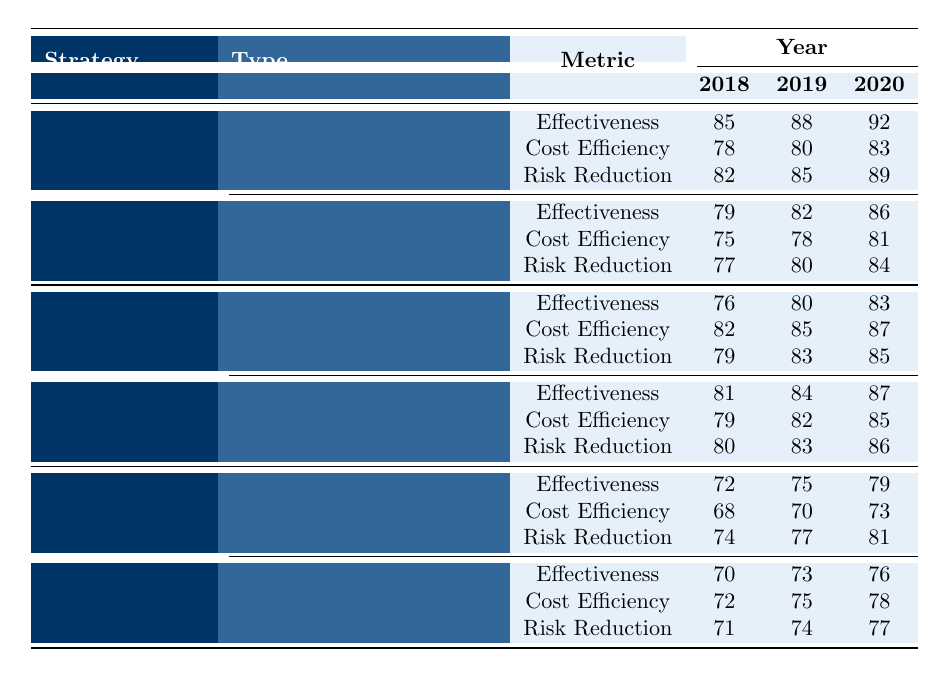What was the effectiveness of Currency Hedging in 2019? In the table under the Currency Hedging type, the effectiveness for the year 2019 is indicated as 88.
Answer: 88 What is the highest Risk Reduction value recorded for Hedging strategies? The highest Risk Reduction value for Hedging strategies is found under Currency Hedging in 2020, which is 89.
Answer: 89 Which diversification type had the highest cost efficiency in 2020? The table shows that Asset Class Diversification had a cost efficiency of 85 in 2020, which is higher than that of Geographic Diversification at 87.
Answer: 85 Did the effectiveness of Credit Default Swaps improve every year? Looking at the effectiveness values for Credit Default Swaps, they increased from 72 in 2018 to 75 in 2019 and then to 79 in 2020, indicating a consistent improvement.
Answer: Yes What was the average effectiveness of Interest Rate Swaps over the three years? The effectiveness values for Interest Rate Swaps are 79, 82, and 86. To find the average, sum them up: 79 + 82 + 86 = 247, and then divide by 3, resulting in 247/3 = 82.33.
Answer: 82.33 What was the cost efficiency of Operational Risk Insurance in 2019? According to the table, the cost efficiency of Operational Risk Insurance in 2019 is listed as 75.
Answer: 75 Which risk mitigation strategy showed the smallest improvement in effectiveness from 2018 to 2020? For the strategies not including Hedging, Geographic Diversification increased from 76 in 2018 to 83 in 2020, showing an increase of 7. In contrast, Credit Default Swaps improved from 72 to 79, which equals an increase of 7 as well. So, both strategies showed the same smallest improvement of 7%.
Answer: Both strategies showed equal improvement Was the effectiveness of Asset Class Diversification higher than Geographic Diversification in all years? The effectiveness values for Asset Class Diversification are 81, 84, and 87, while those for Geographic Diversification are 76, 80, and 83. In all three years, Asset Class Diversification has been higher than or equal to Geographic Diversification.
Answer: Yes In which strategy type did Risk Reduction see the greatest increase from 2018 to 2020? The Risk Reduction values for Credit Default Swaps increased from 74 in 2018 to 81 in 2020, which is an increase of 7 points. In Operational Risk Insurance, it increased from 71 to 77, which is also an increase of 6 points. Credit Default Swaps had the greatest increase of 7 points.
Answer: Credit Default Swaps What is the overall trend in cost efficiency for all risk mitigation strategies from 2018 to 2020? Examining the cost efficiency across all strategies, Hedging maintained a gradual increase, Diversification mostly increased, but Insurance showed mixed results. Overall, there is a positive trend.
Answer: Positive trend 